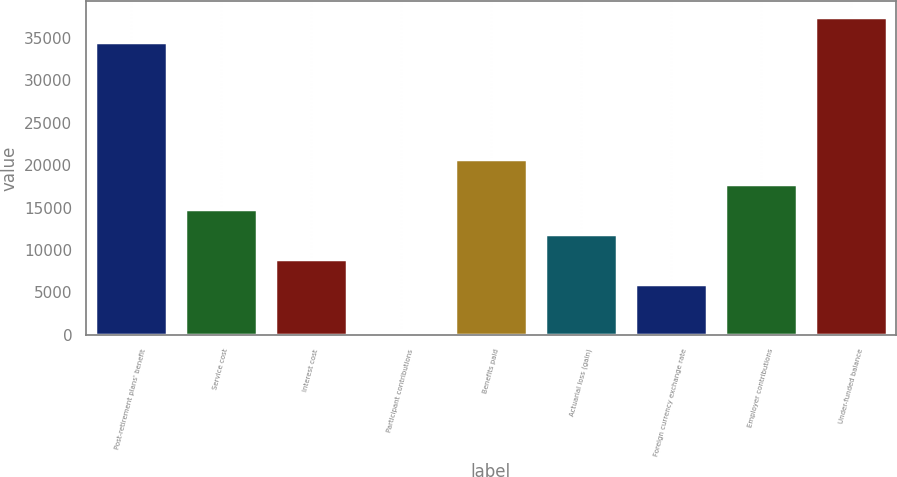<chart> <loc_0><loc_0><loc_500><loc_500><bar_chart><fcel>Post-retirement plans' benefit<fcel>Service cost<fcel>Interest cost<fcel>Participant contributions<fcel>Benefits paid<fcel>Actuarial loss (gain)<fcel>Foreign currency exchange rate<fcel>Employer contributions<fcel>Under-funded balance<nl><fcel>34529.6<fcel>14840<fcel>8976.4<fcel>181<fcel>20703.6<fcel>11908.2<fcel>6044.6<fcel>17771.8<fcel>37461.4<nl></chart> 